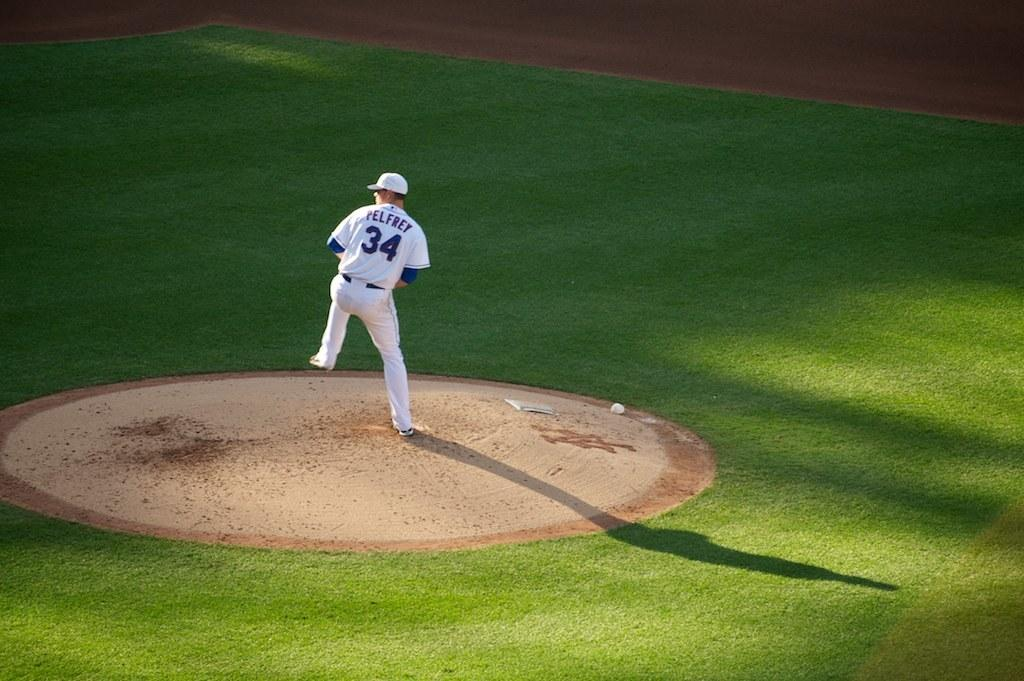<image>
Provide a brief description of the given image. A baseball player with the name Pelfrey and number 34 on his jersey is standing on the pitchers mound. 